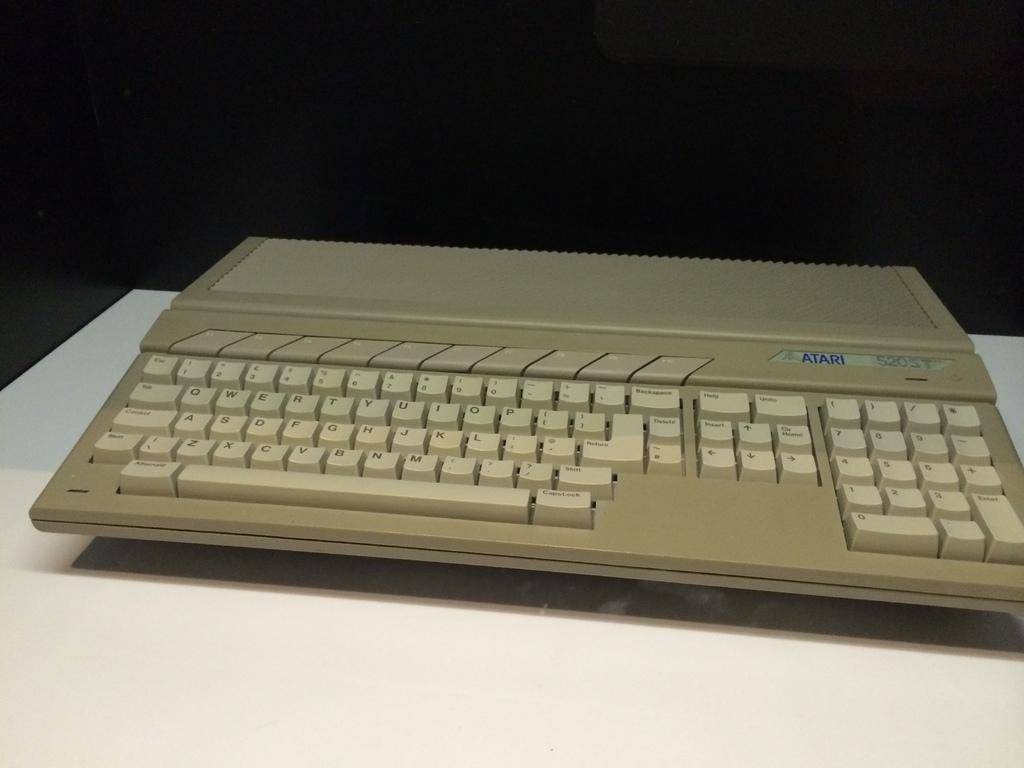Can you describe this image briefly? In this picture we can see a keyboard on the table. 